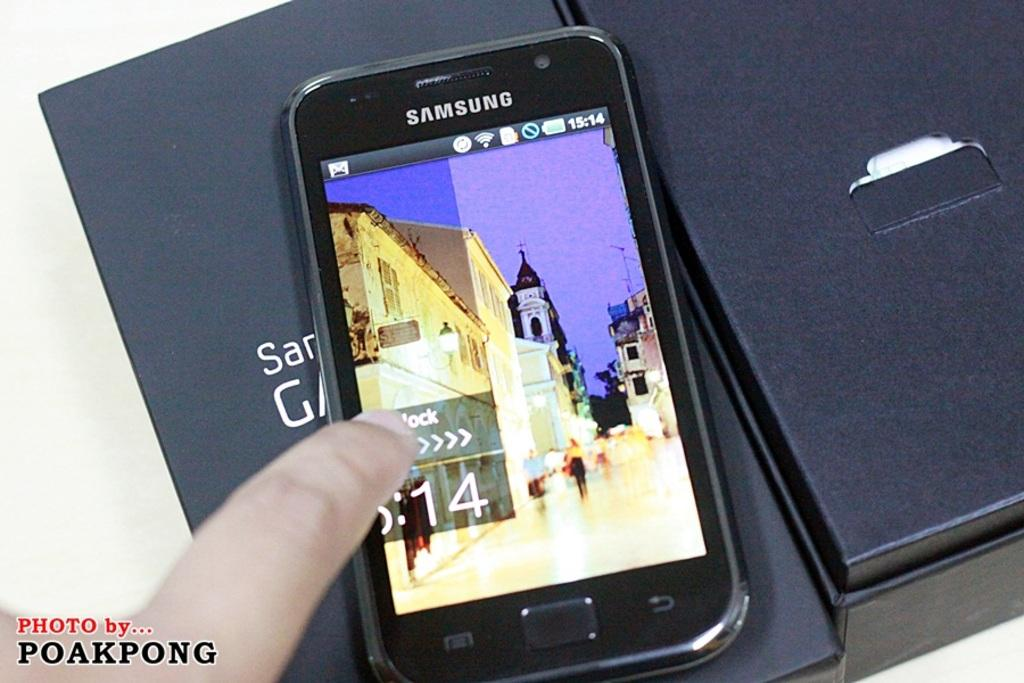Provide a one-sentence caption for the provided image. Poakpong took this photo of a Samsung phone. 